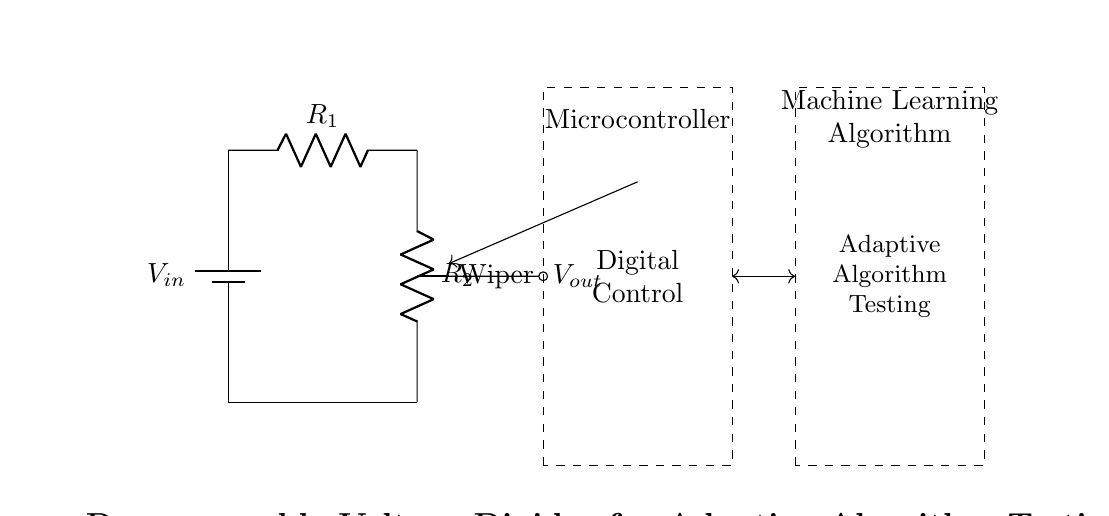What does Vout represent in this circuit? Vout is the output voltage that is taken from the wiper of the digital potentiometer which is connected between R1 and R2. It represents the voltage across the output node relative to the ground.
Answer: Output voltage What are R1 and R2 in this circuit? R1 and R2 are the resistances of the digital potentiometers that form the voltage divider. Their values can be adjusted digitally.
Answer: Digital potentiometers What role does the microcontroller play? The microcontroller controls the digital potentiometers to adjust the resistance values dynamically and respond to the adaptive algorithm testing.
Answer: Control interface How many resistors are present in the circuit? There are two resistors, R1 and R2, which are both digital potentiometers in this circuit.
Answer: Two What type of circuit is this described as? This circuit is specifically designed as a voltage divider, utilizing digital potentiometers for the adjustment of the output voltage in an adaptive testing environment.
Answer: Voltage divider How is the adaptive algorithm tested in this configuration? The adaptive algorithm is tested by adjusting Vout through the configuration of R1 and R2, allowing the system to evaluate different voltage levels programmatically in response to changing requirements.
Answer: Voltage adjustment 